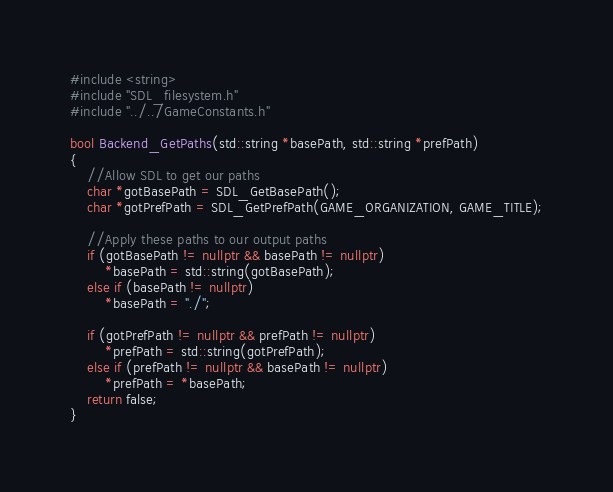<code> <loc_0><loc_0><loc_500><loc_500><_C++_>#include <string>
#include "SDL_filesystem.h"
#include "../../GameConstants.h"

bool Backend_GetPaths(std::string *basePath, std::string *prefPath)
{
	//Allow SDL to get our paths
	char *gotBasePath = SDL_GetBasePath();
	char *gotPrefPath = SDL_GetPrefPath(GAME_ORGANIZATION, GAME_TITLE);
	
	//Apply these paths to our output paths
	if (gotBasePath != nullptr && basePath != nullptr)
		*basePath = std::string(gotBasePath);
	else if (basePath != nullptr)
		*basePath = "./";
	
	if (gotPrefPath != nullptr && prefPath != nullptr)
		*prefPath = std::string(gotPrefPath);
	else if (prefPath != nullptr && basePath != nullptr)
		*prefPath = *basePath;
	return false;
}
</code> 